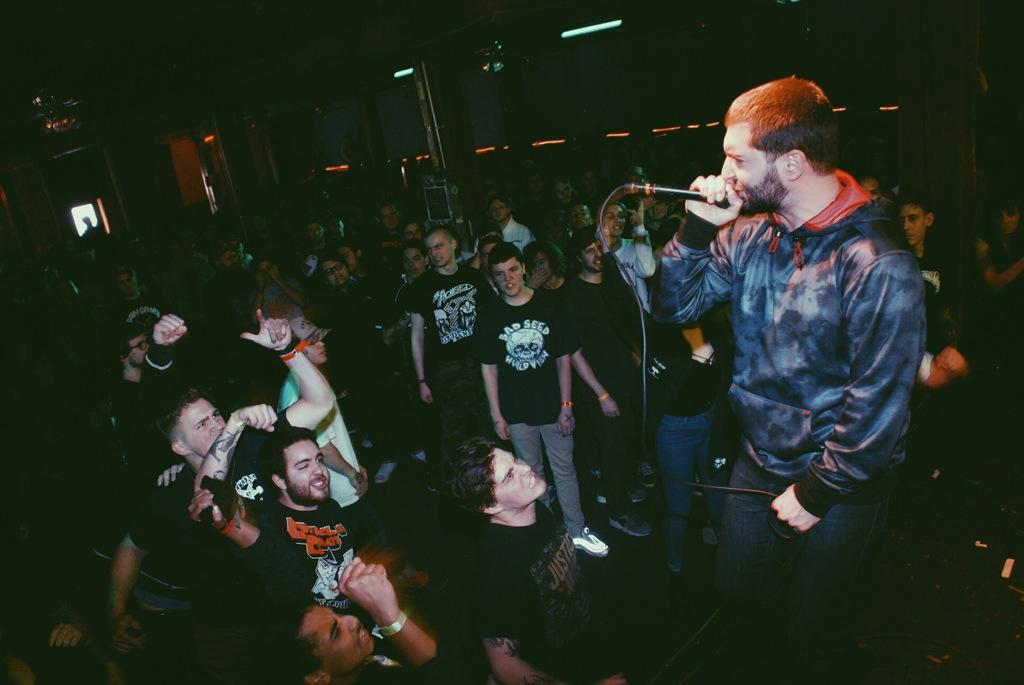What can be seen in the image? There are people in the image. Can you describe the man in the image? A man is standing and holding a microphone with a cable. What is the lighting like in the image? The background of the image is dark, but there are lights visible in the background. What type of experience does the beggar in the image have with the microphone? There is no beggar present in the image; it features a man holding a microphone. Can you describe the bedroom setting in the image? There is no bedroom setting in the image; the background is dark with visible lights. 